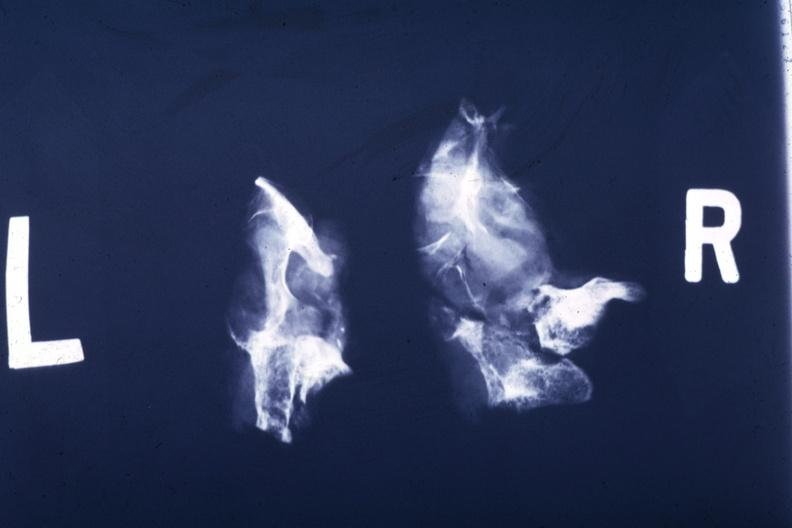s pituitary present?
Answer the question using a single word or phrase. Yes 